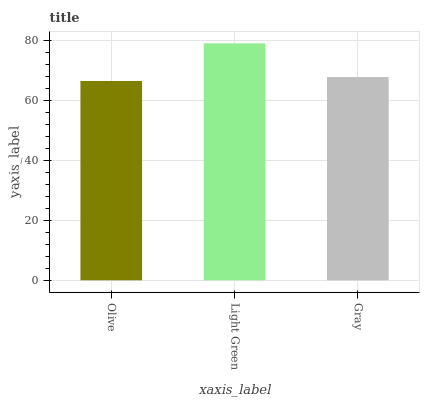Is Olive the minimum?
Answer yes or no. Yes. Is Light Green the maximum?
Answer yes or no. Yes. Is Gray the minimum?
Answer yes or no. No. Is Gray the maximum?
Answer yes or no. No. Is Light Green greater than Gray?
Answer yes or no. Yes. Is Gray less than Light Green?
Answer yes or no. Yes. Is Gray greater than Light Green?
Answer yes or no. No. Is Light Green less than Gray?
Answer yes or no. No. Is Gray the high median?
Answer yes or no. Yes. Is Gray the low median?
Answer yes or no. Yes. Is Olive the high median?
Answer yes or no. No. Is Light Green the low median?
Answer yes or no. No. 